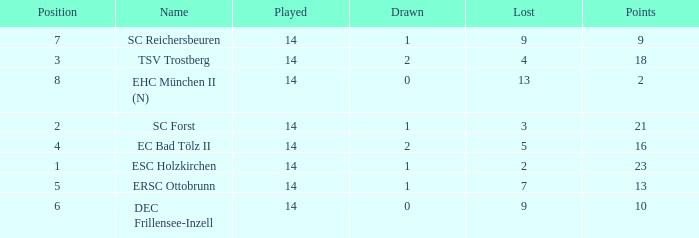Which Points is the highest one that has a Drawn smaller than 2, and a Name of esc holzkirchen, and Played smaller than 14? None. 